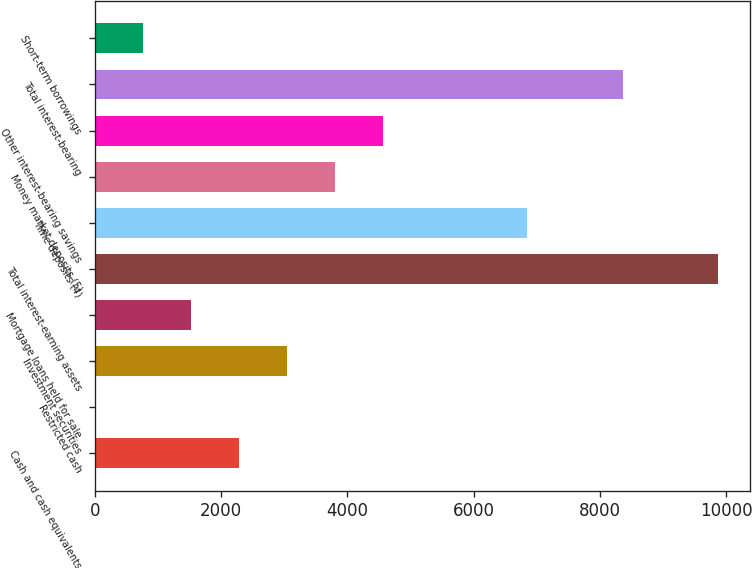Convert chart. <chart><loc_0><loc_0><loc_500><loc_500><bar_chart><fcel>Cash and cash equivalents<fcel>Restricted cash<fcel>Investment securities<fcel>Mortgage loans held for sale<fcel>Total interest-earning assets<fcel>Time deposits (4)<fcel>Money market deposits (5)<fcel>Other interest-bearing savings<fcel>Total interest-bearing<fcel>Short-term borrowings<nl><fcel>2279.5<fcel>1<fcel>3039<fcel>1520<fcel>9874.5<fcel>6836.5<fcel>3798.5<fcel>4558<fcel>8355.5<fcel>760.5<nl></chart> 